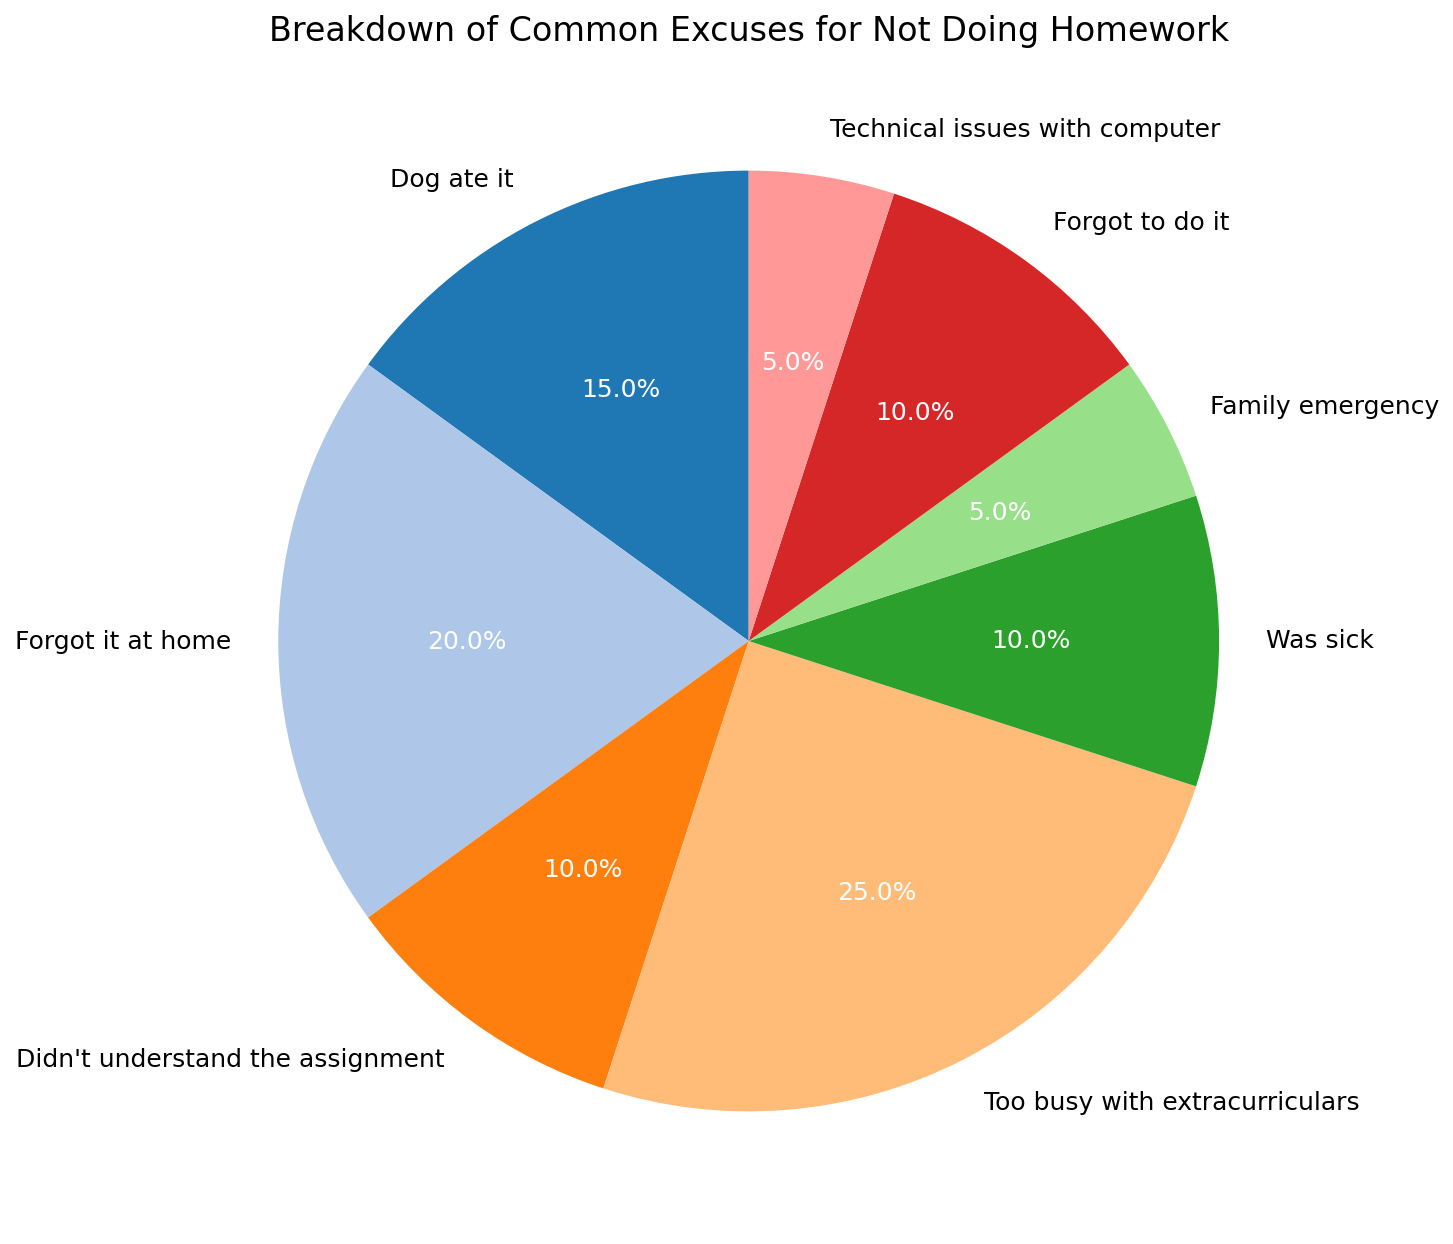What's the percentage of students who said they forgot to do their homework? Identify the slice labeled "Forgot to do it," and refer to the associated percentage in the pie chart.
Answer: 10% Which excuse was the least common according to the chart? Find the slice with the smallest percentage. There are two excuses that share the lowest percentage, "Family emergency" and "Technical issues with computer," each with 5%.
Answer: Family emergency/Technical issues with computer What is the combined percentage of students who either were too busy with extracurriculars or forgot it at home? Add the percentages of "Too busy with extracurriculars" (25%) and "Forgot it at home" (20%). 25% + 20% = 45%
Answer: 45% Which excuse has a higher percentage: "Dog ate it" or "Was sick"? Compare the pie slices for "Dog ate it" (15%) and "Was sick" (10%). 15% is greater than 10%.
Answer: Dog ate it What is the total percentage of students who either didn't understand the assignment or had technical issues with their computer? Add the percentages of "Didn't understand the assignment" (10%) and "Technical issues with computer" (5%). 10% + 5% = 15%
Answer: 15% Which excuse accounted for the largest percentage of reasons given for not doing homework? Identify the slice with the highest percentage; it corresponds to "Too busy with extracurriculars" at 25%.
Answer: Too busy with extracurriculars If we consider only the excuses with an occurrence of 10% or more, what is their total percentage? Sum the percentages of "Dog ate it" (15%), "Forgot it at home" (20%), "Didn't understand the assignment" (10%), "Too busy with extracurriculars" (25%), "Was sick" (10%), and "Forgot to do it" (10%). 15% + 20% + 10% + 25% + 10% + 10% = 90%
Answer: 90% How many excuses have a percentage less than 10%? Identify the slices with percentages less than 10%. They are "Family emergency" (5%) and "Technical issues with computer" (5%). There are 2 such slices.
Answer: 2 Combining the percentages of "Dog ate it," "Didn't understand the assignment," and "Forgot to do it," do they sum to more than the percentage for "Too busy with extracurriculars"? Add the percentages of "Dog ate it" (15%), "Didn't understand the assignment" (10%), and "Forgot to do it" (10%). Compare the sum to "Too busy with extracurriculars" (25%). 15% + 10% + 10% = 35%, which is greater than 25%.
Answer: Yes 